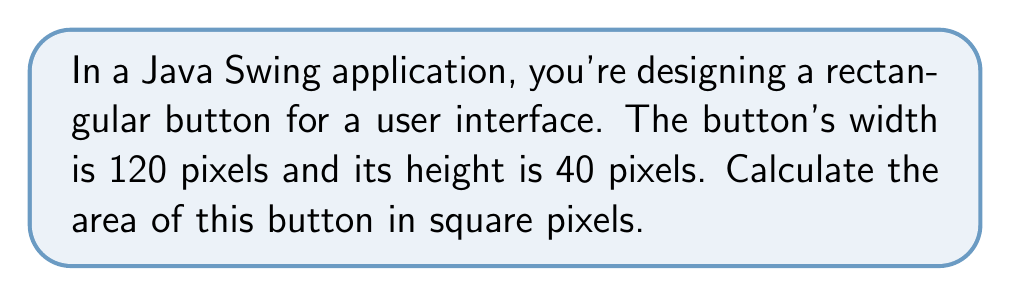Give your solution to this math problem. To find the area of a rectangle, we use the formula:

$$ A = w \times h $$

Where:
$A$ = area
$w$ = width
$h$ = height

Given:
- Width (w) = 120 pixels
- Height (h) = 40 pixels

Let's substitute these values into the formula:

$$ A = 120 \times 40 $$

Now, let's perform the multiplication:

$$ A = 4800 $$

Therefore, the area of the rectangular button is 4800 square pixels.

This calculation is useful in GUI development, as it helps determine the space occupied by UI elements, which is crucial for layout management and ensuring proper element sizing in Java Swing applications.
Answer: $4800 \text{ sq pixels}$ 